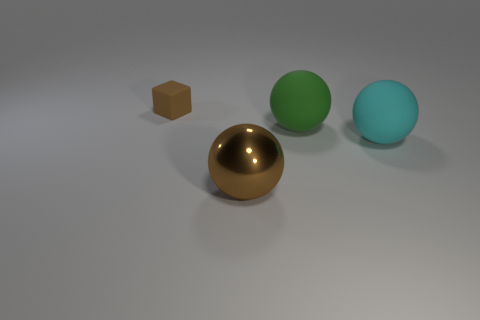Is there any other thing that has the same size as the cyan sphere?
Give a very brief answer. Yes. There is a large cyan thing that is the same shape as the green object; what is its material?
Offer a very short reply. Rubber. What shape is the thing behind the big rubber ball that is behind the cyan sphere?
Provide a succinct answer. Cube. Do the large ball behind the cyan matte object and the cube have the same material?
Ensure brevity in your answer.  Yes. Is the number of green spheres that are behind the tiny thing the same as the number of green balls that are left of the large cyan sphere?
Your response must be concise. No. What material is the object that is the same color as the small block?
Your answer should be very brief. Metal. How many large cyan matte things are left of the big matte sphere that is on the right side of the green ball?
Provide a short and direct response. 0. Do the object that is to the left of the metallic sphere and the object that is on the right side of the large green sphere have the same color?
Provide a succinct answer. No. What material is the green thing that is the same size as the cyan sphere?
Ensure brevity in your answer.  Rubber. There is a tiny rubber object behind the large object behind the large thing that is on the right side of the large green matte object; what shape is it?
Your answer should be compact. Cube. 